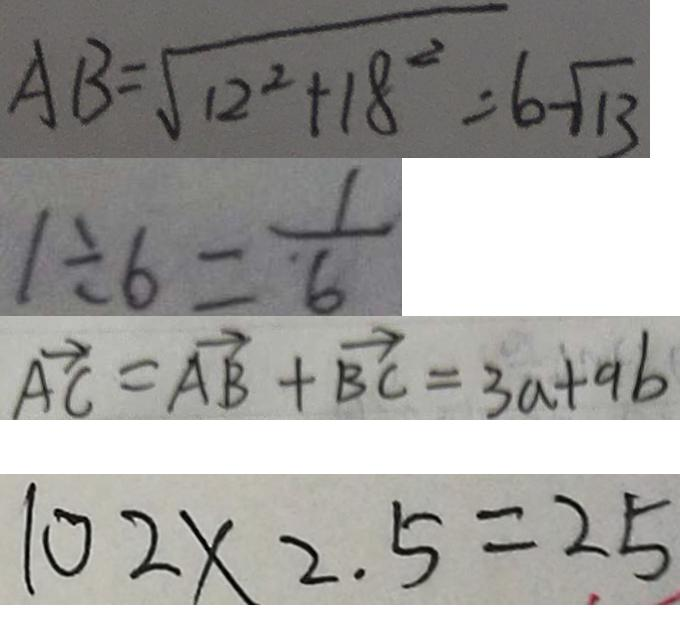Convert formula to latex. <formula><loc_0><loc_0><loc_500><loc_500>A B = \sqrt { 1 2 ^ { 2 } + 1 8 ^ { 2 } } = 6 \sqrt { 1 3 } 
 1 \div 6 = \frac { 1 } { 6 } 
 \overrightarrow { A C } = \overrightarrow { A B } + \overrightarrow { B C } = 3 a + a b 
 1 0 2 \times 2 . 5 = 2 5</formula> 